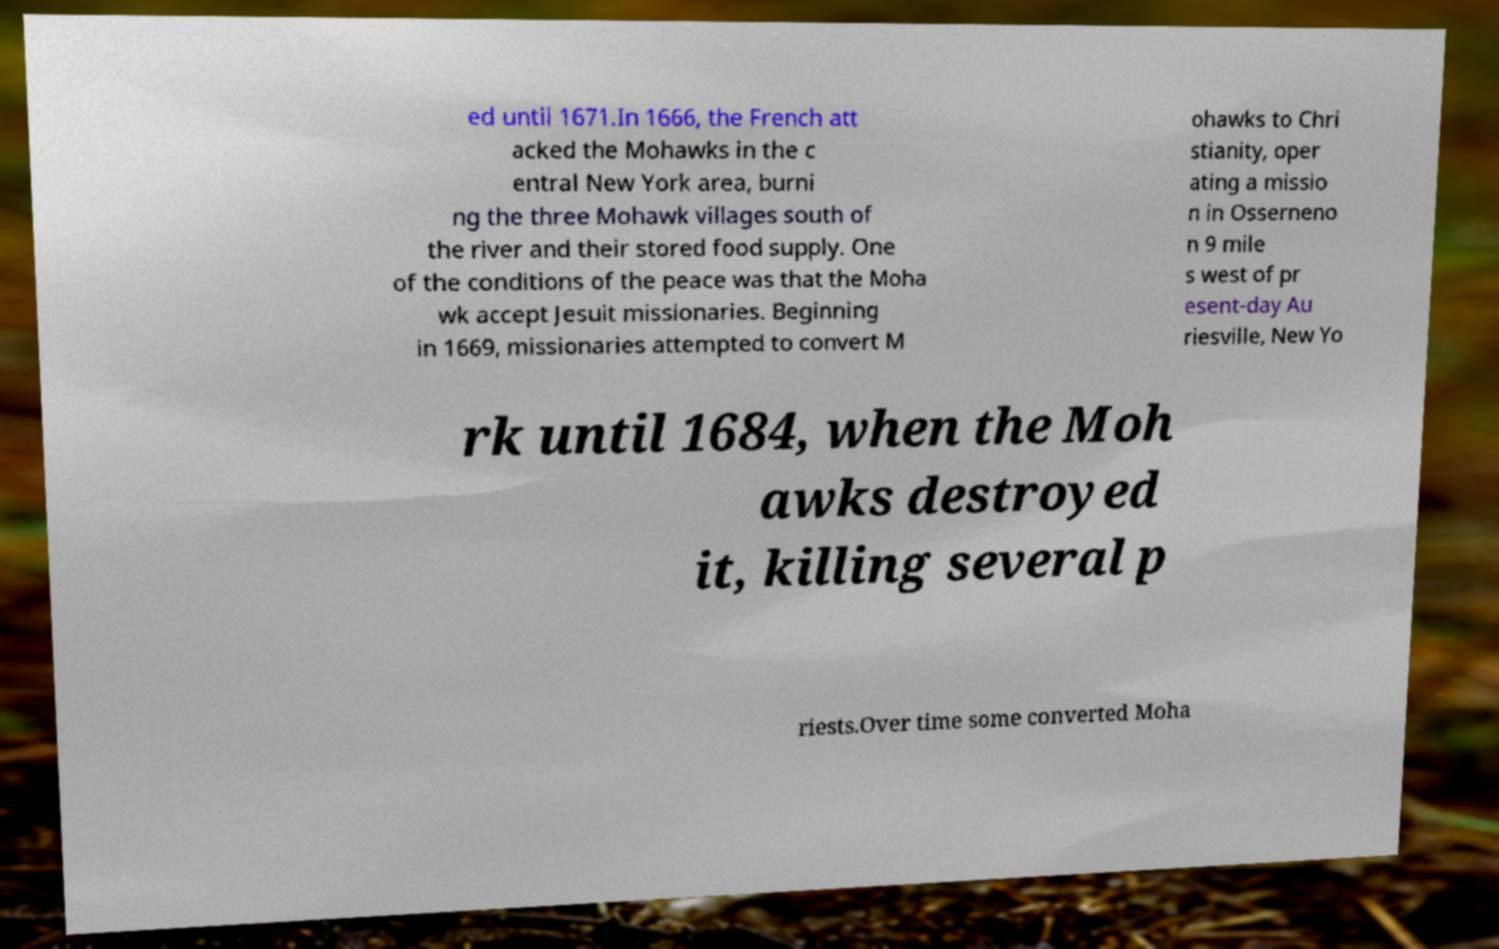Please read and relay the text visible in this image. What does it say? ed until 1671.In 1666, the French att acked the Mohawks in the c entral New York area, burni ng the three Mohawk villages south of the river and their stored food supply. One of the conditions of the peace was that the Moha wk accept Jesuit missionaries. Beginning in 1669, missionaries attempted to convert M ohawks to Chri stianity, oper ating a missio n in Osserneno n 9 mile s west of pr esent-day Au riesville, New Yo rk until 1684, when the Moh awks destroyed it, killing several p riests.Over time some converted Moha 